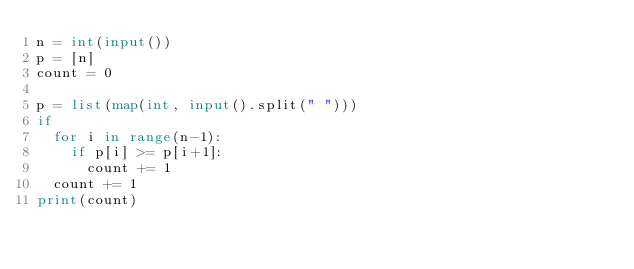Convert code to text. <code><loc_0><loc_0><loc_500><loc_500><_Python_>n = int(input())
p = [n]
count = 0

p = list(map(int, input().split(" ")))
if 
	for i in range(n-1):
		if p[i] >= p[i+1]:
			count += 1
	count += 1
print(count)</code> 